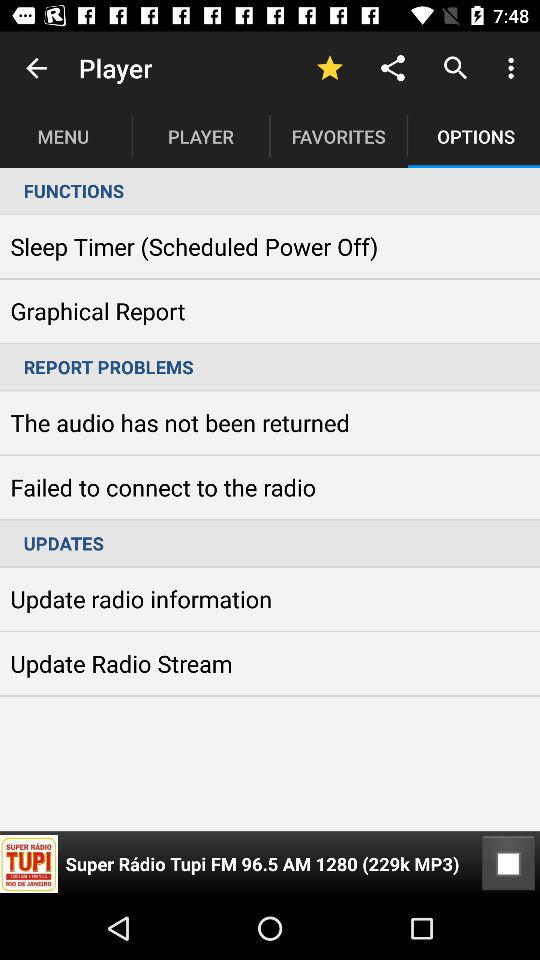What is the currently playing audio? The currently playing audio is "Super Rádio Tupi FM 96.5 AM 1280 (229k MP3)". 